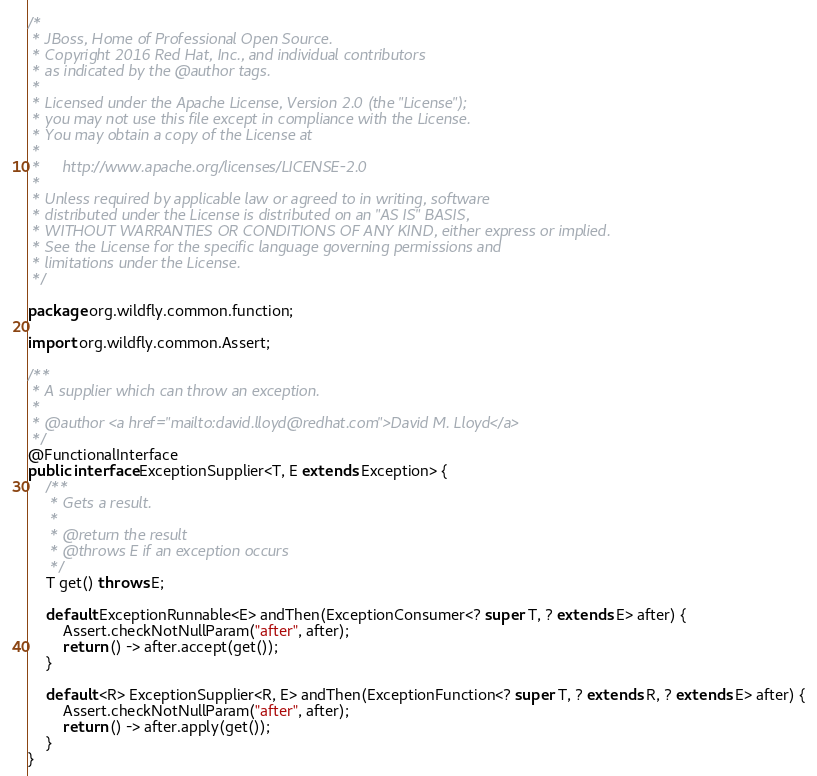Convert code to text. <code><loc_0><loc_0><loc_500><loc_500><_Java_>/*
 * JBoss, Home of Professional Open Source.
 * Copyright 2016 Red Hat, Inc., and individual contributors
 * as indicated by the @author tags.
 *
 * Licensed under the Apache License, Version 2.0 (the "License");
 * you may not use this file except in compliance with the License.
 * You may obtain a copy of the License at
 *
 *     http://www.apache.org/licenses/LICENSE-2.0
 *
 * Unless required by applicable law or agreed to in writing, software
 * distributed under the License is distributed on an "AS IS" BASIS,
 * WITHOUT WARRANTIES OR CONDITIONS OF ANY KIND, either express or implied.
 * See the License for the specific language governing permissions and
 * limitations under the License.
 */

package org.wildfly.common.function;

import org.wildfly.common.Assert;

/**
 * A supplier which can throw an exception.
 *
 * @author <a href="mailto:david.lloyd@redhat.com">David M. Lloyd</a>
 */
@FunctionalInterface
public interface ExceptionSupplier<T, E extends Exception> {
    /**
     * Gets a result.
     *
     * @return the result
     * @throws E if an exception occurs
     */
    T get() throws E;

    default ExceptionRunnable<E> andThen(ExceptionConsumer<? super T, ? extends E> after) {
        Assert.checkNotNullParam("after", after);
        return () -> after.accept(get());
    }

    default <R> ExceptionSupplier<R, E> andThen(ExceptionFunction<? super T, ? extends R, ? extends E> after) {
        Assert.checkNotNullParam("after", after);
        return () -> after.apply(get());
    }
}
</code> 